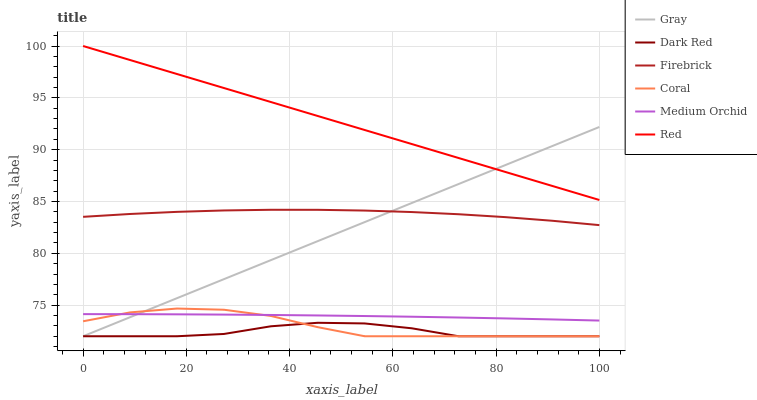Does Dark Red have the minimum area under the curve?
Answer yes or no. Yes. Does Red have the maximum area under the curve?
Answer yes or no. Yes. Does Firebrick have the minimum area under the curve?
Answer yes or no. No. Does Firebrick have the maximum area under the curve?
Answer yes or no. No. Is Red the smoothest?
Answer yes or no. Yes. Is Coral the roughest?
Answer yes or no. Yes. Is Dark Red the smoothest?
Answer yes or no. No. Is Dark Red the roughest?
Answer yes or no. No. Does Firebrick have the lowest value?
Answer yes or no. No. Does Red have the highest value?
Answer yes or no. Yes. Does Firebrick have the highest value?
Answer yes or no. No. Is Coral less than Firebrick?
Answer yes or no. Yes. Is Red greater than Firebrick?
Answer yes or no. Yes. Does Gray intersect Coral?
Answer yes or no. Yes. Is Gray less than Coral?
Answer yes or no. No. Is Gray greater than Coral?
Answer yes or no. No. Does Coral intersect Firebrick?
Answer yes or no. No. 